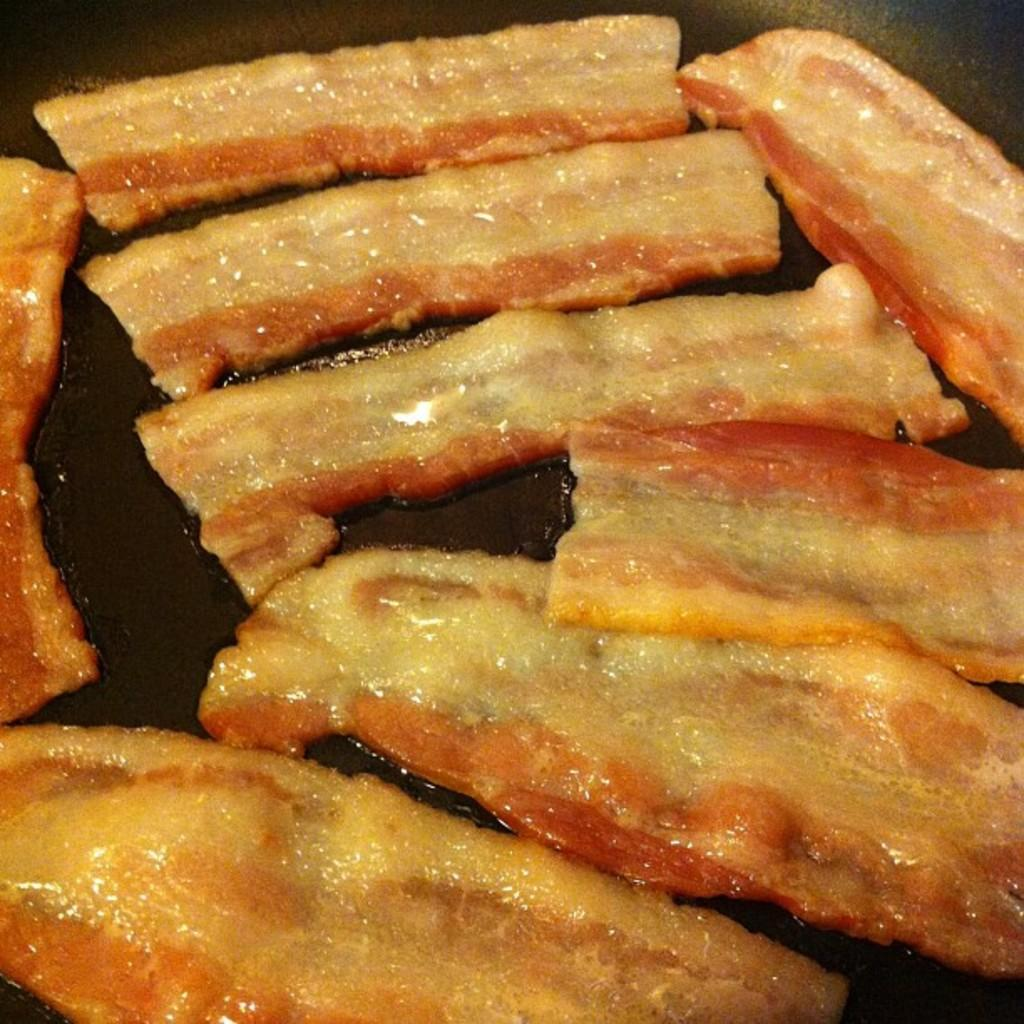What type of food is being prepared in the image? There are bacon or eatables in the image that are being fried in oil. How is the food being cooked in the image? The bacon or eatables are frying in oil. What type of underwear is the father wearing in the image? There is no father or underwear present in the image; it only features bacon or eatables frying in oil. 